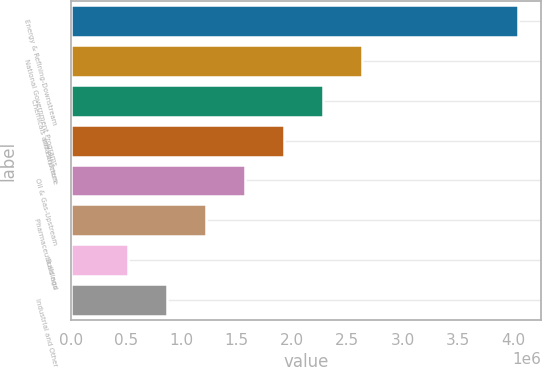Convert chart to OTSL. <chart><loc_0><loc_0><loc_500><loc_500><bar_chart><fcel>Energy & Refining-Downstream<fcel>National Government Programs<fcel>Chemicals and Polymers<fcel>Infrastructure<fcel>Oil & Gas-Upstream<fcel>Pharmaceuticals and<fcel>Buildings<fcel>Industrial and Other<nl><fcel>4.04779e+06<fcel>2.63551e+06<fcel>2.28244e+06<fcel>1.92937e+06<fcel>1.5763e+06<fcel>1.22323e+06<fcel>517085<fcel>870155<nl></chart> 